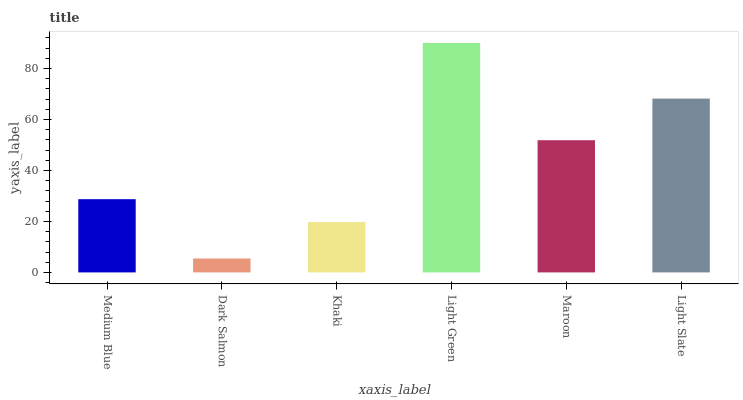Is Khaki the minimum?
Answer yes or no. No. Is Khaki the maximum?
Answer yes or no. No. Is Khaki greater than Dark Salmon?
Answer yes or no. Yes. Is Dark Salmon less than Khaki?
Answer yes or no. Yes. Is Dark Salmon greater than Khaki?
Answer yes or no. No. Is Khaki less than Dark Salmon?
Answer yes or no. No. Is Maroon the high median?
Answer yes or no. Yes. Is Medium Blue the low median?
Answer yes or no. Yes. Is Dark Salmon the high median?
Answer yes or no. No. Is Light Green the low median?
Answer yes or no. No. 